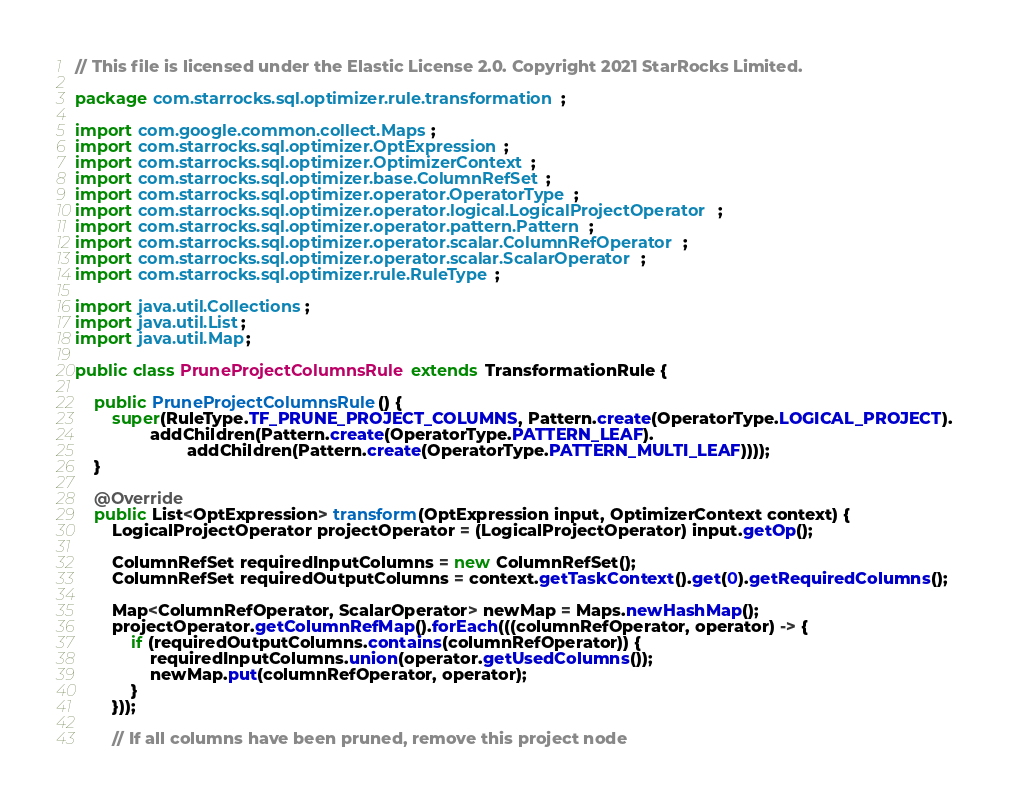<code> <loc_0><loc_0><loc_500><loc_500><_Java_>// This file is licensed under the Elastic License 2.0. Copyright 2021 StarRocks Limited.

package com.starrocks.sql.optimizer.rule.transformation;

import com.google.common.collect.Maps;
import com.starrocks.sql.optimizer.OptExpression;
import com.starrocks.sql.optimizer.OptimizerContext;
import com.starrocks.sql.optimizer.base.ColumnRefSet;
import com.starrocks.sql.optimizer.operator.OperatorType;
import com.starrocks.sql.optimizer.operator.logical.LogicalProjectOperator;
import com.starrocks.sql.optimizer.operator.pattern.Pattern;
import com.starrocks.sql.optimizer.operator.scalar.ColumnRefOperator;
import com.starrocks.sql.optimizer.operator.scalar.ScalarOperator;
import com.starrocks.sql.optimizer.rule.RuleType;

import java.util.Collections;
import java.util.List;
import java.util.Map;

public class PruneProjectColumnsRule extends TransformationRule {

    public PruneProjectColumnsRule() {
        super(RuleType.TF_PRUNE_PROJECT_COLUMNS, Pattern.create(OperatorType.LOGICAL_PROJECT).
                addChildren(Pattern.create(OperatorType.PATTERN_LEAF).
                        addChildren(Pattern.create(OperatorType.PATTERN_MULTI_LEAF))));
    }

    @Override
    public List<OptExpression> transform(OptExpression input, OptimizerContext context) {
        LogicalProjectOperator projectOperator = (LogicalProjectOperator) input.getOp();

        ColumnRefSet requiredInputColumns = new ColumnRefSet();
        ColumnRefSet requiredOutputColumns = context.getTaskContext().get(0).getRequiredColumns();

        Map<ColumnRefOperator, ScalarOperator> newMap = Maps.newHashMap();
        projectOperator.getColumnRefMap().forEach(((columnRefOperator, operator) -> {
            if (requiredOutputColumns.contains(columnRefOperator)) {
                requiredInputColumns.union(operator.getUsedColumns());
                newMap.put(columnRefOperator, operator);
            }
        }));

        // If all columns have been pruned, remove this project node</code> 